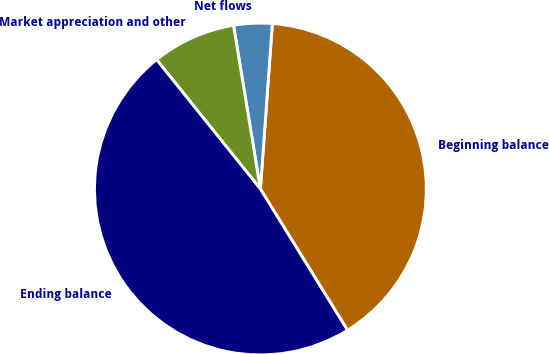Convert chart. <chart><loc_0><loc_0><loc_500><loc_500><pie_chart><fcel>Beginning balance<fcel>Net flows<fcel>Market appreciation and other<fcel>Ending balance<nl><fcel>40.05%<fcel>3.74%<fcel>8.17%<fcel>48.03%<nl></chart> 